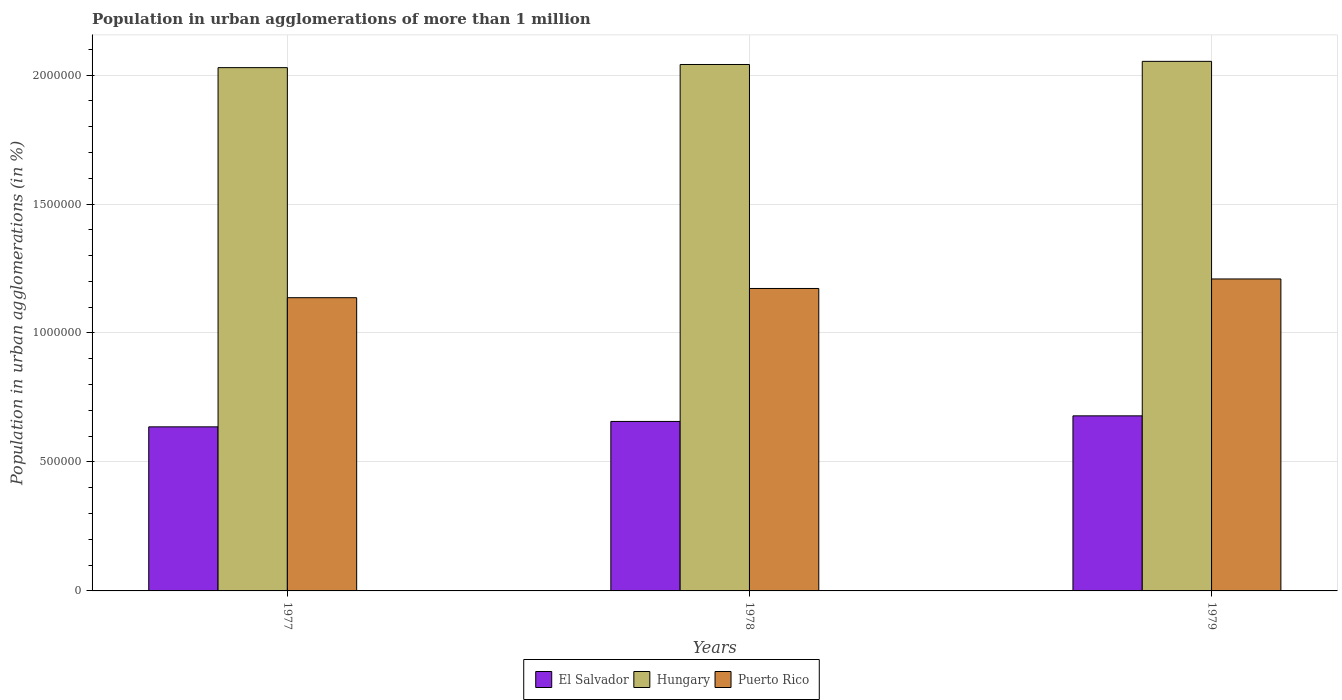How many different coloured bars are there?
Your response must be concise. 3. Are the number of bars on each tick of the X-axis equal?
Keep it short and to the point. Yes. What is the label of the 2nd group of bars from the left?
Provide a short and direct response. 1978. In how many cases, is the number of bars for a given year not equal to the number of legend labels?
Make the answer very short. 0. What is the population in urban agglomerations in El Salvador in 1978?
Your answer should be very brief. 6.57e+05. Across all years, what is the maximum population in urban agglomerations in Hungary?
Provide a succinct answer. 2.05e+06. Across all years, what is the minimum population in urban agglomerations in El Salvador?
Offer a very short reply. 6.36e+05. In which year was the population in urban agglomerations in Puerto Rico maximum?
Keep it short and to the point. 1979. What is the total population in urban agglomerations in Hungary in the graph?
Your answer should be very brief. 6.12e+06. What is the difference between the population in urban agglomerations in Puerto Rico in 1978 and that in 1979?
Your answer should be very brief. -3.69e+04. What is the difference between the population in urban agglomerations in El Salvador in 1977 and the population in urban agglomerations in Puerto Rico in 1979?
Your answer should be compact. -5.73e+05. What is the average population in urban agglomerations in El Salvador per year?
Your answer should be compact. 6.57e+05. In the year 1978, what is the difference between the population in urban agglomerations in Hungary and population in urban agglomerations in El Salvador?
Keep it short and to the point. 1.38e+06. In how many years, is the population in urban agglomerations in Hungary greater than 200000 %?
Make the answer very short. 3. What is the ratio of the population in urban agglomerations in Puerto Rico in 1977 to that in 1978?
Make the answer very short. 0.97. Is the difference between the population in urban agglomerations in Hungary in 1978 and 1979 greater than the difference between the population in urban agglomerations in El Salvador in 1978 and 1979?
Offer a terse response. Yes. What is the difference between the highest and the second highest population in urban agglomerations in El Salvador?
Keep it short and to the point. 2.17e+04. What is the difference between the highest and the lowest population in urban agglomerations in El Salvador?
Offer a very short reply. 4.26e+04. Is the sum of the population in urban agglomerations in Hungary in 1978 and 1979 greater than the maximum population in urban agglomerations in El Salvador across all years?
Provide a short and direct response. Yes. What does the 3rd bar from the left in 1978 represents?
Offer a terse response. Puerto Rico. What does the 2nd bar from the right in 1979 represents?
Keep it short and to the point. Hungary. Are all the bars in the graph horizontal?
Give a very brief answer. No. How many years are there in the graph?
Give a very brief answer. 3. Does the graph contain grids?
Provide a succinct answer. Yes. Where does the legend appear in the graph?
Ensure brevity in your answer.  Bottom center. How many legend labels are there?
Make the answer very short. 3. How are the legend labels stacked?
Offer a very short reply. Horizontal. What is the title of the graph?
Your answer should be very brief. Population in urban agglomerations of more than 1 million. What is the label or title of the X-axis?
Your response must be concise. Years. What is the label or title of the Y-axis?
Your response must be concise. Population in urban agglomerations (in %). What is the Population in urban agglomerations (in %) in El Salvador in 1977?
Your response must be concise. 6.36e+05. What is the Population in urban agglomerations (in %) in Hungary in 1977?
Give a very brief answer. 2.03e+06. What is the Population in urban agglomerations (in %) in Puerto Rico in 1977?
Your answer should be very brief. 1.14e+06. What is the Population in urban agglomerations (in %) of El Salvador in 1978?
Give a very brief answer. 6.57e+05. What is the Population in urban agglomerations (in %) of Hungary in 1978?
Provide a succinct answer. 2.04e+06. What is the Population in urban agglomerations (in %) of Puerto Rico in 1978?
Your answer should be compact. 1.17e+06. What is the Population in urban agglomerations (in %) of El Salvador in 1979?
Your answer should be compact. 6.79e+05. What is the Population in urban agglomerations (in %) in Hungary in 1979?
Offer a terse response. 2.05e+06. What is the Population in urban agglomerations (in %) of Puerto Rico in 1979?
Provide a short and direct response. 1.21e+06. Across all years, what is the maximum Population in urban agglomerations (in %) in El Salvador?
Offer a very short reply. 6.79e+05. Across all years, what is the maximum Population in urban agglomerations (in %) in Hungary?
Make the answer very short. 2.05e+06. Across all years, what is the maximum Population in urban agglomerations (in %) of Puerto Rico?
Make the answer very short. 1.21e+06. Across all years, what is the minimum Population in urban agglomerations (in %) of El Salvador?
Your answer should be compact. 6.36e+05. Across all years, what is the minimum Population in urban agglomerations (in %) in Hungary?
Give a very brief answer. 2.03e+06. Across all years, what is the minimum Population in urban agglomerations (in %) of Puerto Rico?
Keep it short and to the point. 1.14e+06. What is the total Population in urban agglomerations (in %) of El Salvador in the graph?
Your answer should be compact. 1.97e+06. What is the total Population in urban agglomerations (in %) in Hungary in the graph?
Ensure brevity in your answer.  6.12e+06. What is the total Population in urban agglomerations (in %) in Puerto Rico in the graph?
Your answer should be compact. 3.52e+06. What is the difference between the Population in urban agglomerations (in %) of El Salvador in 1977 and that in 1978?
Offer a terse response. -2.10e+04. What is the difference between the Population in urban agglomerations (in %) in Hungary in 1977 and that in 1978?
Your answer should be very brief. -1.21e+04. What is the difference between the Population in urban agglomerations (in %) of Puerto Rico in 1977 and that in 1978?
Keep it short and to the point. -3.58e+04. What is the difference between the Population in urban agglomerations (in %) in El Salvador in 1977 and that in 1979?
Give a very brief answer. -4.26e+04. What is the difference between the Population in urban agglomerations (in %) in Hungary in 1977 and that in 1979?
Provide a short and direct response. -2.43e+04. What is the difference between the Population in urban agglomerations (in %) in Puerto Rico in 1977 and that in 1979?
Provide a succinct answer. -7.26e+04. What is the difference between the Population in urban agglomerations (in %) in El Salvador in 1978 and that in 1979?
Provide a short and direct response. -2.17e+04. What is the difference between the Population in urban agglomerations (in %) in Hungary in 1978 and that in 1979?
Make the answer very short. -1.22e+04. What is the difference between the Population in urban agglomerations (in %) of Puerto Rico in 1978 and that in 1979?
Your answer should be compact. -3.69e+04. What is the difference between the Population in urban agglomerations (in %) of El Salvador in 1977 and the Population in urban agglomerations (in %) of Hungary in 1978?
Ensure brevity in your answer.  -1.40e+06. What is the difference between the Population in urban agglomerations (in %) of El Salvador in 1977 and the Population in urban agglomerations (in %) of Puerto Rico in 1978?
Keep it short and to the point. -5.36e+05. What is the difference between the Population in urban agglomerations (in %) of Hungary in 1977 and the Population in urban agglomerations (in %) of Puerto Rico in 1978?
Give a very brief answer. 8.56e+05. What is the difference between the Population in urban agglomerations (in %) of El Salvador in 1977 and the Population in urban agglomerations (in %) of Hungary in 1979?
Your answer should be compact. -1.42e+06. What is the difference between the Population in urban agglomerations (in %) in El Salvador in 1977 and the Population in urban agglomerations (in %) in Puerto Rico in 1979?
Provide a short and direct response. -5.73e+05. What is the difference between the Population in urban agglomerations (in %) in Hungary in 1977 and the Population in urban agglomerations (in %) in Puerto Rico in 1979?
Your answer should be very brief. 8.19e+05. What is the difference between the Population in urban agglomerations (in %) in El Salvador in 1978 and the Population in urban agglomerations (in %) in Hungary in 1979?
Give a very brief answer. -1.40e+06. What is the difference between the Population in urban agglomerations (in %) of El Salvador in 1978 and the Population in urban agglomerations (in %) of Puerto Rico in 1979?
Give a very brief answer. -5.52e+05. What is the difference between the Population in urban agglomerations (in %) of Hungary in 1978 and the Population in urban agglomerations (in %) of Puerto Rico in 1979?
Your response must be concise. 8.31e+05. What is the average Population in urban agglomerations (in %) in El Salvador per year?
Keep it short and to the point. 6.57e+05. What is the average Population in urban agglomerations (in %) in Hungary per year?
Give a very brief answer. 2.04e+06. What is the average Population in urban agglomerations (in %) in Puerto Rico per year?
Provide a short and direct response. 1.17e+06. In the year 1977, what is the difference between the Population in urban agglomerations (in %) in El Salvador and Population in urban agglomerations (in %) in Hungary?
Your answer should be very brief. -1.39e+06. In the year 1977, what is the difference between the Population in urban agglomerations (in %) in El Salvador and Population in urban agglomerations (in %) in Puerto Rico?
Provide a short and direct response. -5.01e+05. In the year 1977, what is the difference between the Population in urban agglomerations (in %) of Hungary and Population in urban agglomerations (in %) of Puerto Rico?
Provide a succinct answer. 8.92e+05. In the year 1978, what is the difference between the Population in urban agglomerations (in %) of El Salvador and Population in urban agglomerations (in %) of Hungary?
Your response must be concise. -1.38e+06. In the year 1978, what is the difference between the Population in urban agglomerations (in %) of El Salvador and Population in urban agglomerations (in %) of Puerto Rico?
Offer a very short reply. -5.16e+05. In the year 1978, what is the difference between the Population in urban agglomerations (in %) in Hungary and Population in urban agglomerations (in %) in Puerto Rico?
Provide a short and direct response. 8.68e+05. In the year 1979, what is the difference between the Population in urban agglomerations (in %) in El Salvador and Population in urban agglomerations (in %) in Hungary?
Give a very brief answer. -1.37e+06. In the year 1979, what is the difference between the Population in urban agglomerations (in %) in El Salvador and Population in urban agglomerations (in %) in Puerto Rico?
Your answer should be compact. -5.31e+05. In the year 1979, what is the difference between the Population in urban agglomerations (in %) in Hungary and Population in urban agglomerations (in %) in Puerto Rico?
Provide a succinct answer. 8.44e+05. What is the ratio of the Population in urban agglomerations (in %) in El Salvador in 1977 to that in 1978?
Provide a succinct answer. 0.97. What is the ratio of the Population in urban agglomerations (in %) in Puerto Rico in 1977 to that in 1978?
Make the answer very short. 0.97. What is the ratio of the Population in urban agglomerations (in %) in El Salvador in 1977 to that in 1979?
Provide a short and direct response. 0.94. What is the ratio of the Population in urban agglomerations (in %) in Hungary in 1977 to that in 1979?
Give a very brief answer. 0.99. What is the ratio of the Population in urban agglomerations (in %) in Puerto Rico in 1977 to that in 1979?
Ensure brevity in your answer.  0.94. What is the ratio of the Population in urban agglomerations (in %) of El Salvador in 1978 to that in 1979?
Your response must be concise. 0.97. What is the ratio of the Population in urban agglomerations (in %) of Puerto Rico in 1978 to that in 1979?
Make the answer very short. 0.97. What is the difference between the highest and the second highest Population in urban agglomerations (in %) in El Salvador?
Ensure brevity in your answer.  2.17e+04. What is the difference between the highest and the second highest Population in urban agglomerations (in %) in Hungary?
Keep it short and to the point. 1.22e+04. What is the difference between the highest and the second highest Population in urban agglomerations (in %) in Puerto Rico?
Make the answer very short. 3.69e+04. What is the difference between the highest and the lowest Population in urban agglomerations (in %) in El Salvador?
Ensure brevity in your answer.  4.26e+04. What is the difference between the highest and the lowest Population in urban agglomerations (in %) in Hungary?
Your answer should be very brief. 2.43e+04. What is the difference between the highest and the lowest Population in urban agglomerations (in %) in Puerto Rico?
Ensure brevity in your answer.  7.26e+04. 